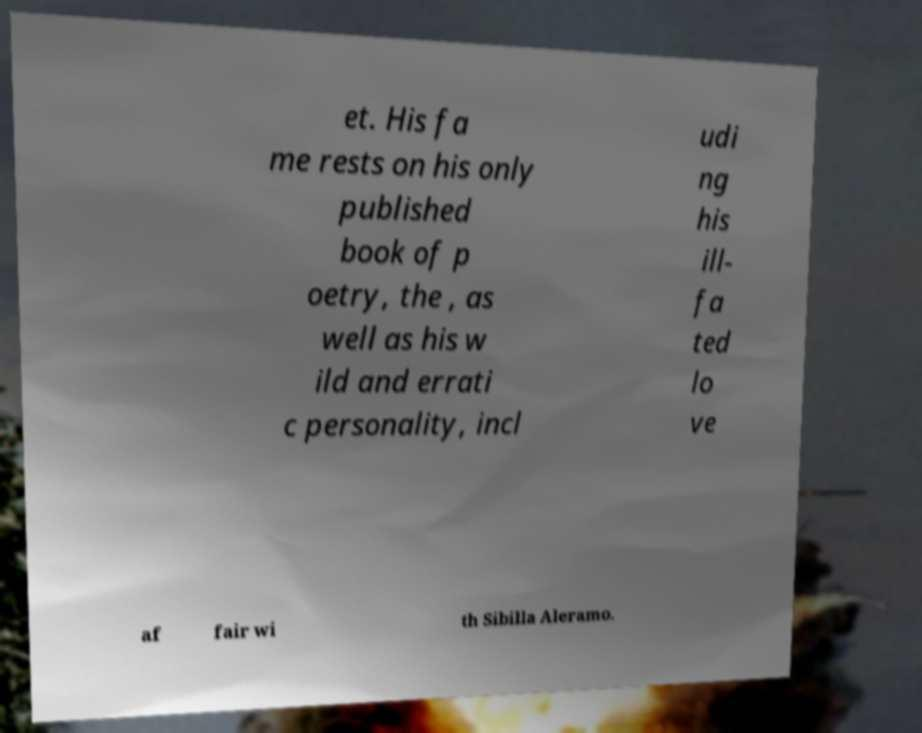Could you extract and type out the text from this image? et. His fa me rests on his only published book of p oetry, the , as well as his w ild and errati c personality, incl udi ng his ill- fa ted lo ve af fair wi th Sibilla Aleramo. 